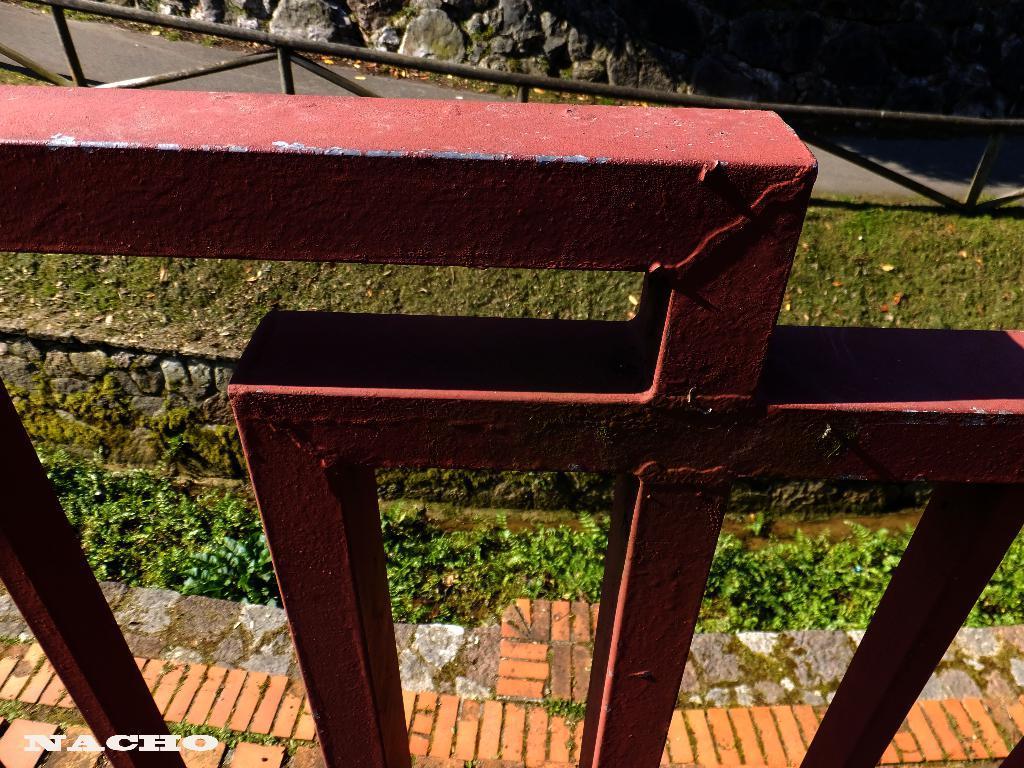In one or two sentences, can you explain what this image depicts? In the picture there is an iron fence, there is a floor, beside the floor there are plants, there is a wall, there are stones present. 